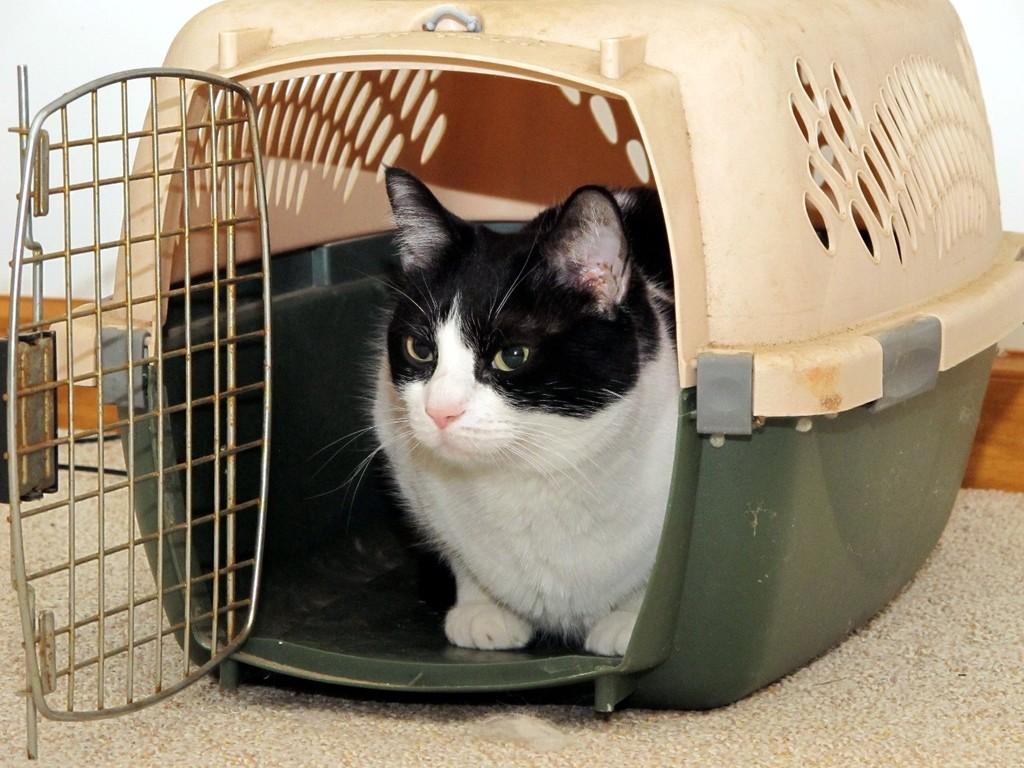What type of animal is in the image? There is a cat in the image. Where is the cat located in the image? The cat is sitting in a cage. What is the cage resting on in the image? The cage is on a surface. What color is the background of the image? The background of the image is white in color. What type of metal is the chicken made of in the image? There is no chicken present in the image, and therefore no metal chicken can be observed. 